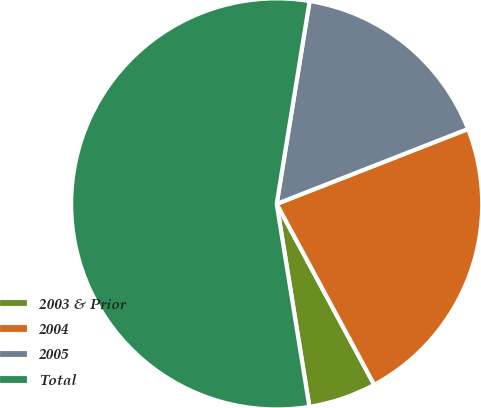Convert chart. <chart><loc_0><loc_0><loc_500><loc_500><pie_chart><fcel>2003 & Prior<fcel>2004<fcel>2005<fcel>Total<nl><fcel>5.33%<fcel>23.07%<fcel>16.5%<fcel>55.11%<nl></chart> 